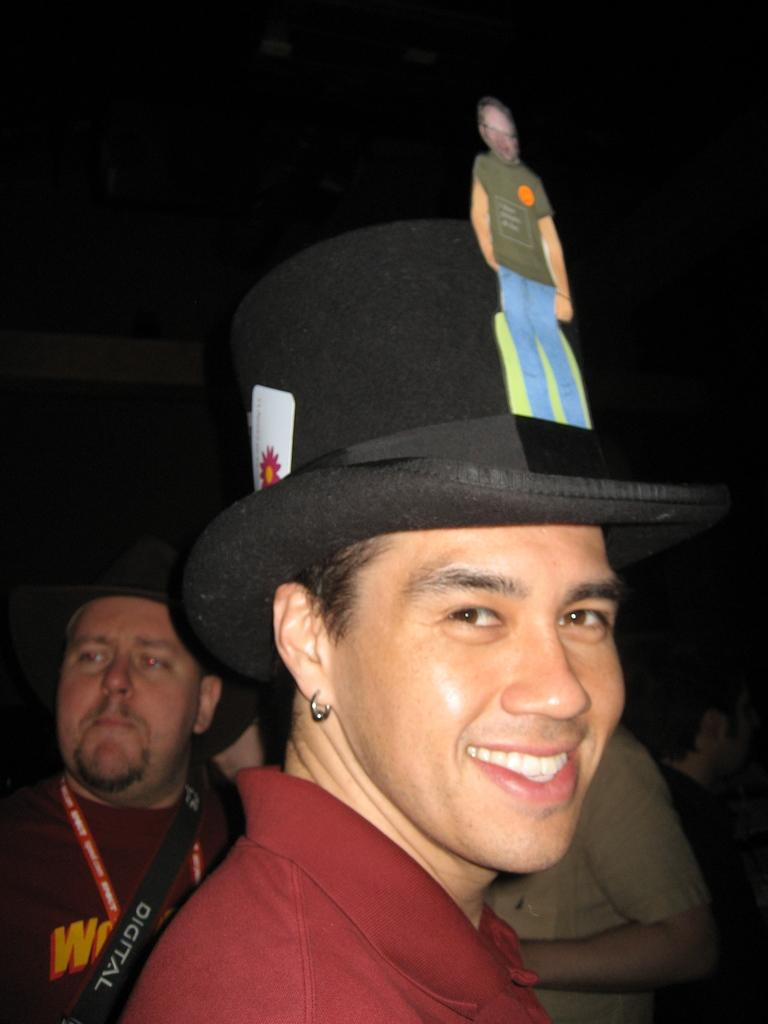What is the main subject of the image? There is a person in the image. Can you describe the person's appearance? The person is wearing a hat and smiling. Are there any other people in the image? Yes, there are two other people behind the person with the hat. What is the weight of the person in the image? The weight of the person in the image cannot be determined from the image alone. What is the name of the person in the image? The name of the person in the image is not mentioned or visible in the image. 